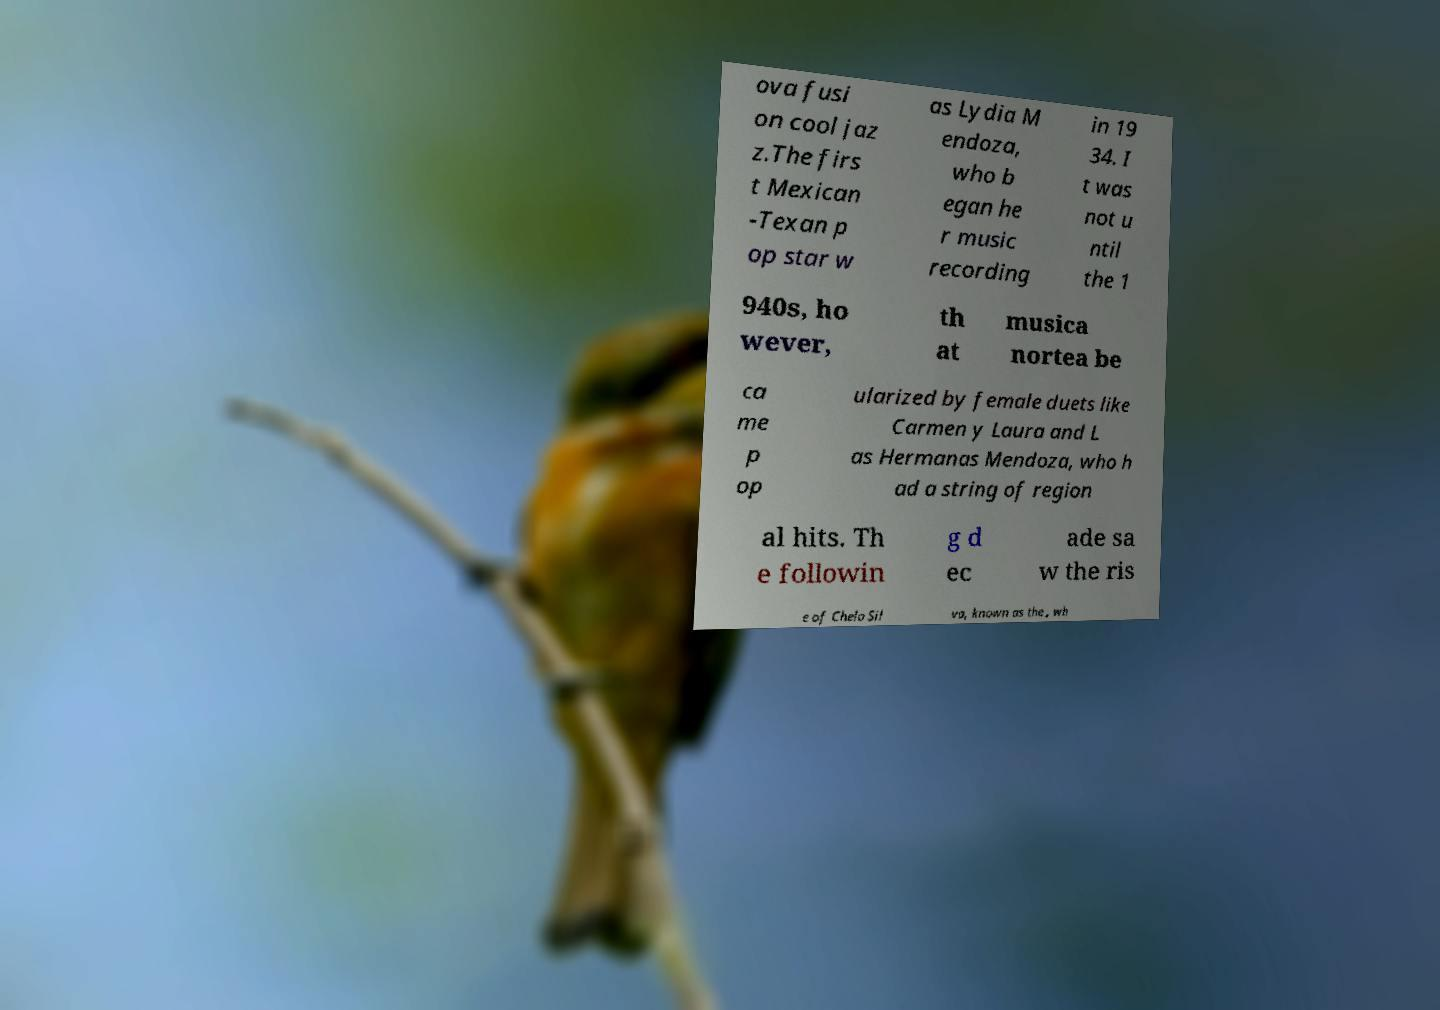Could you extract and type out the text from this image? ova fusi on cool jaz z.The firs t Mexican -Texan p op star w as Lydia M endoza, who b egan he r music recording in 19 34. I t was not u ntil the 1 940s, ho wever, th at musica nortea be ca me p op ularized by female duets like Carmen y Laura and L as Hermanas Mendoza, who h ad a string of region al hits. Th e followin g d ec ade sa w the ris e of Chelo Sil va, known as the , wh 